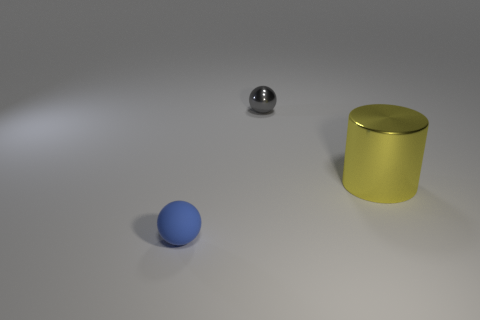Is there a gray thing of the same size as the matte sphere?
Make the answer very short. Yes. What is the object that is both to the right of the small blue thing and on the left side of the cylinder made of?
Ensure brevity in your answer.  Metal. What number of metallic objects are yellow cylinders or small cyan balls?
Offer a terse response. 1. There is a large yellow thing that is the same material as the gray thing; what is its shape?
Ensure brevity in your answer.  Cylinder. What number of things are both on the left side of the big thing and on the right side of the small blue rubber thing?
Your answer should be compact. 1. Are there any other things that have the same shape as the large object?
Give a very brief answer. No. How big is the sphere behind the blue sphere?
Your answer should be very brief. Small. There is a ball on the right side of the small sphere in front of the big cylinder; what is it made of?
Your answer should be compact. Metal. There is a object that is on the left side of the gray object; does it have the same color as the big cylinder?
Provide a succinct answer. No. Is there any other thing that has the same material as the cylinder?
Offer a terse response. Yes. 